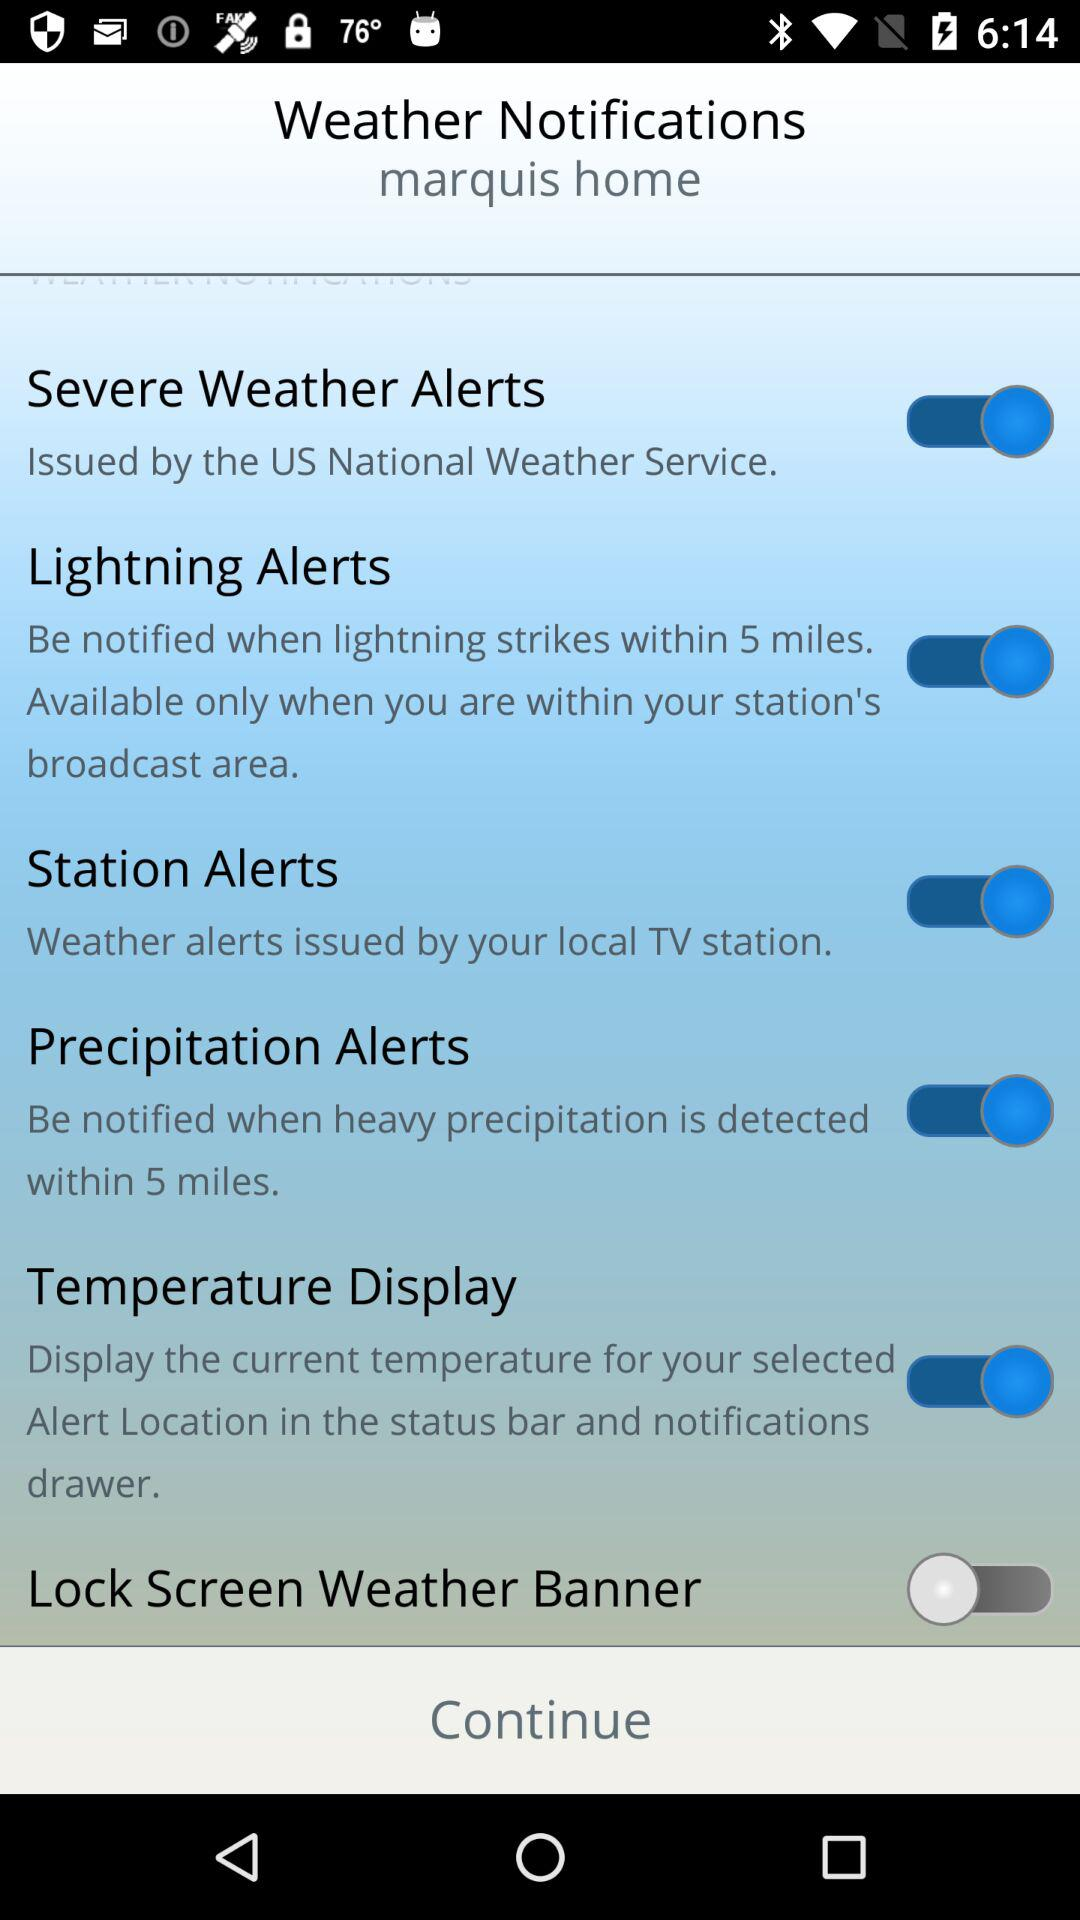Which weather notification is "off"? The weather notification that is "off" is "Lock Screen Weather Banner". 